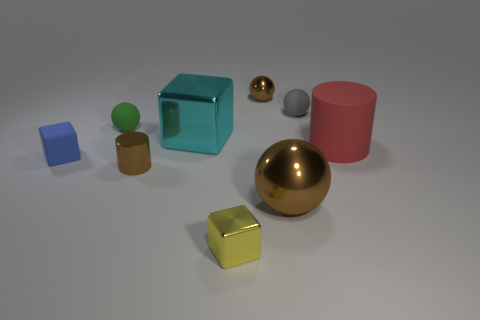Add 1 tiny gray rubber spheres. How many objects exist? 10 Subtract all spheres. How many objects are left? 5 Add 2 tiny metal spheres. How many tiny metal spheres exist? 3 Subtract 1 gray balls. How many objects are left? 8 Subtract all small green things. Subtract all gray spheres. How many objects are left? 7 Add 2 yellow blocks. How many yellow blocks are left? 3 